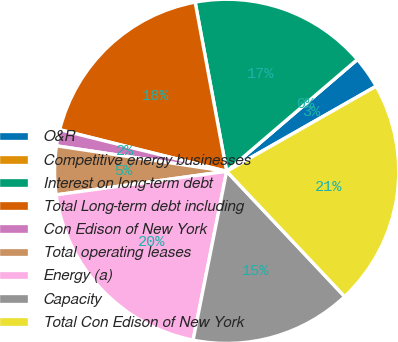Convert chart to OTSL. <chart><loc_0><loc_0><loc_500><loc_500><pie_chart><fcel>O&R<fcel>Competitive energy businesses<fcel>Interest on long-term debt<fcel>Total Long-term debt including<fcel>Con Edison of New York<fcel>Total operating leases<fcel>Energy (a)<fcel>Capacity<fcel>Total Con Edison of New York<nl><fcel>3.03%<fcel>0.0%<fcel>16.66%<fcel>18.18%<fcel>1.52%<fcel>4.55%<fcel>19.69%<fcel>15.15%<fcel>21.21%<nl></chart> 